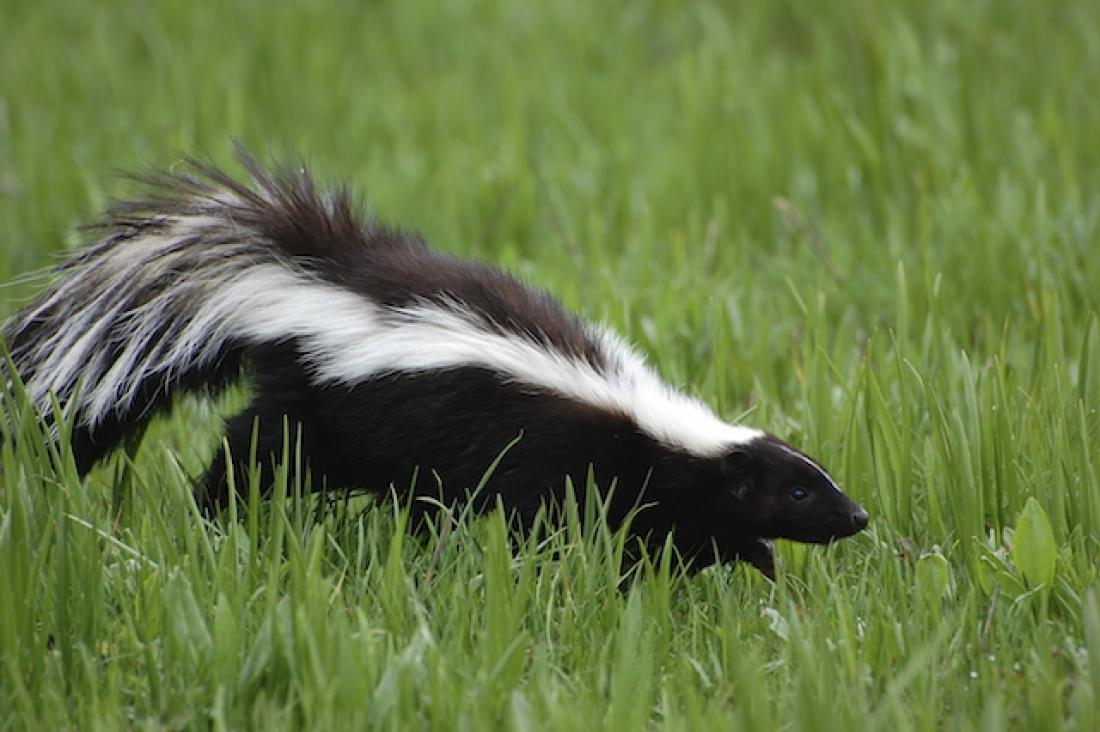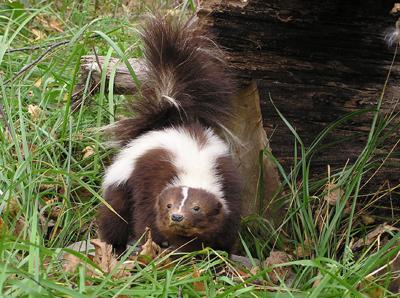The first image is the image on the left, the second image is the image on the right. Examine the images to the left and right. Is the description "The left image contains one forward-facing skunk, and the right image includes a skunk on all fours with its body turned leftward." accurate? Answer yes or no. No. The first image is the image on the left, the second image is the image on the right. For the images shown, is this caption "At least one skunk is in the grass." true? Answer yes or no. Yes. 